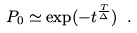<formula> <loc_0><loc_0><loc_500><loc_500>P _ { 0 } \simeq \exp ( - t ^ { \frac { T } { \Delta } } ) \ .</formula> 